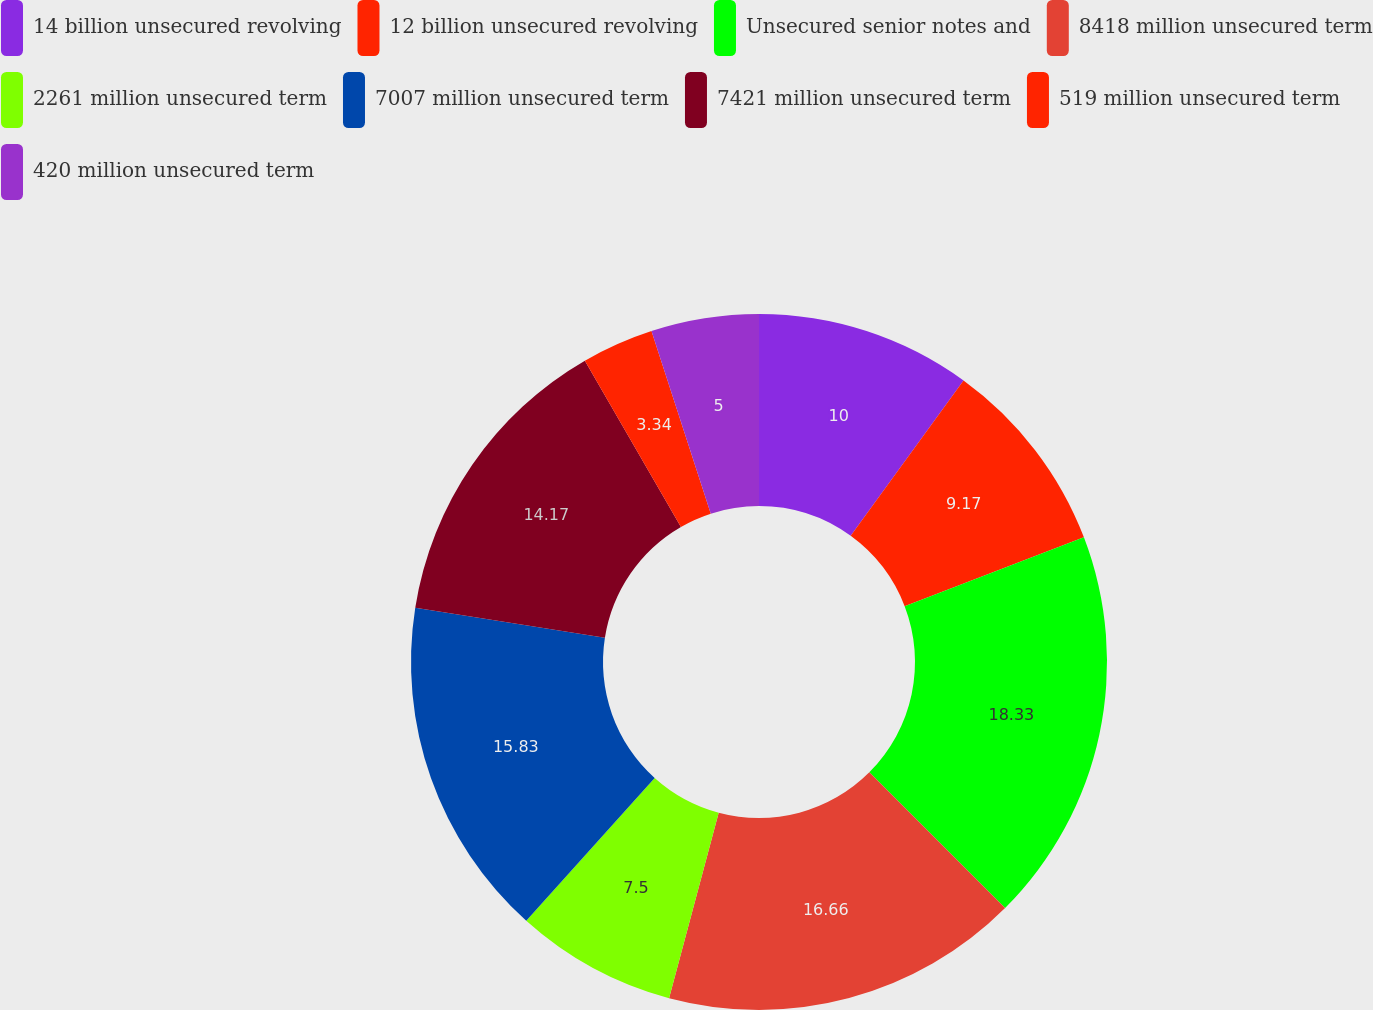Convert chart to OTSL. <chart><loc_0><loc_0><loc_500><loc_500><pie_chart><fcel>14 billion unsecured revolving<fcel>12 billion unsecured revolving<fcel>Unsecured senior notes and<fcel>8418 million unsecured term<fcel>2261 million unsecured term<fcel>7007 million unsecured term<fcel>7421 million unsecured term<fcel>519 million unsecured term<fcel>420 million unsecured term<nl><fcel>10.0%<fcel>9.17%<fcel>18.33%<fcel>16.66%<fcel>7.5%<fcel>15.83%<fcel>14.17%<fcel>3.34%<fcel>5.0%<nl></chart> 